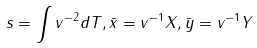<formula> <loc_0><loc_0><loc_500><loc_500>s = \int v ^ { - 2 } d T , \bar { x } = v ^ { - 1 } X , \bar { y } = v ^ { - 1 } Y</formula> 